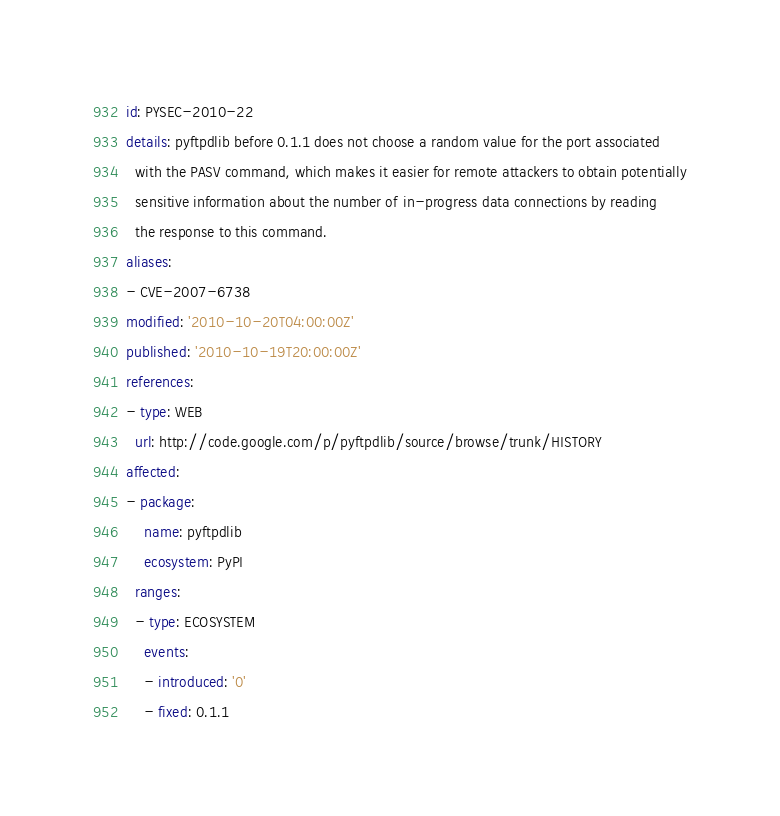Convert code to text. <code><loc_0><loc_0><loc_500><loc_500><_YAML_>id: PYSEC-2010-22
details: pyftpdlib before 0.1.1 does not choose a random value for the port associated
  with the PASV command, which makes it easier for remote attackers to obtain potentially
  sensitive information about the number of in-progress data connections by reading
  the response to this command.
aliases:
- CVE-2007-6738
modified: '2010-10-20T04:00:00Z'
published: '2010-10-19T20:00:00Z'
references:
- type: WEB
  url: http://code.google.com/p/pyftpdlib/source/browse/trunk/HISTORY
affected:
- package:
    name: pyftpdlib
    ecosystem: PyPI
  ranges:
  - type: ECOSYSTEM
    events:
    - introduced: '0'
    - fixed: 0.1.1
</code> 